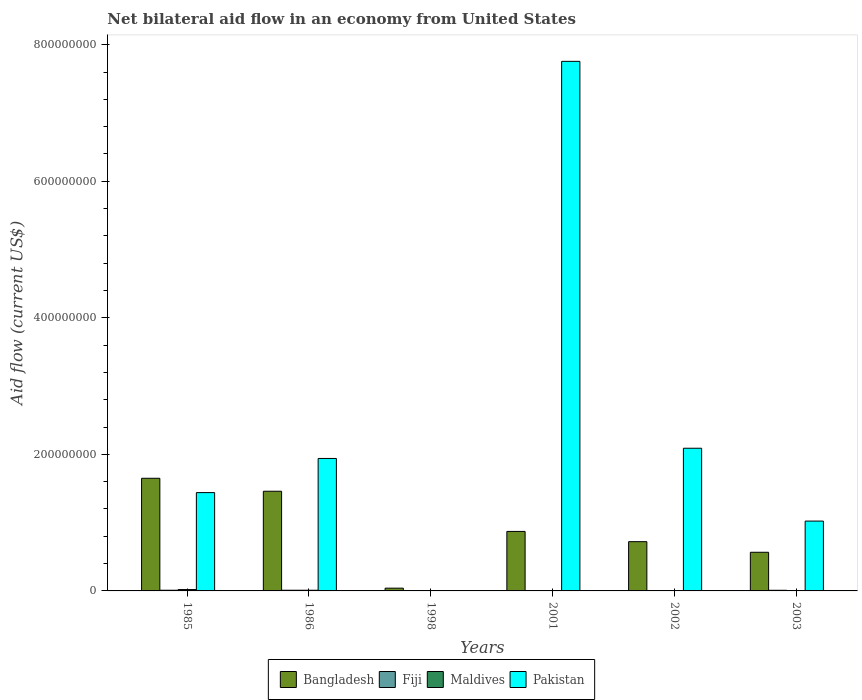Are the number of bars per tick equal to the number of legend labels?
Your answer should be compact. No. How many bars are there on the 5th tick from the right?
Provide a succinct answer. 4. What is the net bilateral aid flow in Bangladesh in 2003?
Ensure brevity in your answer.  5.66e+07. Across all years, what is the maximum net bilateral aid flow in Maldives?
Provide a short and direct response. 2.00e+06. In which year was the net bilateral aid flow in Bangladesh maximum?
Give a very brief answer. 1985. What is the total net bilateral aid flow in Maldives in the graph?
Provide a succinct answer. 3.00e+06. What is the difference between the net bilateral aid flow in Fiji in 1986 and that in 2001?
Offer a very short reply. 9.90e+05. What is the difference between the net bilateral aid flow in Pakistan in 1986 and the net bilateral aid flow in Bangladesh in 2002?
Your response must be concise. 1.22e+08. What is the average net bilateral aid flow in Fiji per year?
Offer a very short reply. 5.42e+05. In the year 2003, what is the difference between the net bilateral aid flow in Fiji and net bilateral aid flow in Pakistan?
Offer a terse response. -1.01e+08. In how many years, is the net bilateral aid flow in Bangladesh greater than 280000000 US$?
Your answer should be very brief. 0. What is the ratio of the net bilateral aid flow in Bangladesh in 1998 to that in 2001?
Your response must be concise. 0.05. What is the difference between the highest and the second highest net bilateral aid flow in Bangladesh?
Provide a succinct answer. 1.90e+07. What is the difference between the highest and the lowest net bilateral aid flow in Bangladesh?
Ensure brevity in your answer.  1.61e+08. In how many years, is the net bilateral aid flow in Bangladesh greater than the average net bilateral aid flow in Bangladesh taken over all years?
Your response must be concise. 2. Is it the case that in every year, the sum of the net bilateral aid flow in Bangladesh and net bilateral aid flow in Fiji is greater than the sum of net bilateral aid flow in Pakistan and net bilateral aid flow in Maldives?
Ensure brevity in your answer.  No. How many bars are there?
Make the answer very short. 19. Are all the bars in the graph horizontal?
Provide a short and direct response. No. Are the values on the major ticks of Y-axis written in scientific E-notation?
Keep it short and to the point. No. Does the graph contain any zero values?
Provide a succinct answer. Yes. Where does the legend appear in the graph?
Ensure brevity in your answer.  Bottom center. What is the title of the graph?
Your answer should be compact. Net bilateral aid flow in an economy from United States. Does "Pakistan" appear as one of the legend labels in the graph?
Your response must be concise. Yes. What is the label or title of the X-axis?
Offer a terse response. Years. What is the label or title of the Y-axis?
Provide a succinct answer. Aid flow (current US$). What is the Aid flow (current US$) in Bangladesh in 1985?
Give a very brief answer. 1.65e+08. What is the Aid flow (current US$) of Pakistan in 1985?
Your answer should be very brief. 1.44e+08. What is the Aid flow (current US$) in Bangladesh in 1986?
Offer a terse response. 1.46e+08. What is the Aid flow (current US$) of Pakistan in 1986?
Your answer should be very brief. 1.94e+08. What is the Aid flow (current US$) of Bangladesh in 1998?
Your response must be concise. 4.04e+06. What is the Aid flow (current US$) of Pakistan in 1998?
Your answer should be very brief. 0. What is the Aid flow (current US$) of Bangladesh in 2001?
Make the answer very short. 8.71e+07. What is the Aid flow (current US$) of Pakistan in 2001?
Your answer should be compact. 7.76e+08. What is the Aid flow (current US$) of Bangladesh in 2002?
Make the answer very short. 7.21e+07. What is the Aid flow (current US$) of Maldives in 2002?
Ensure brevity in your answer.  0. What is the Aid flow (current US$) of Pakistan in 2002?
Make the answer very short. 2.09e+08. What is the Aid flow (current US$) in Bangladesh in 2003?
Offer a terse response. 5.66e+07. What is the Aid flow (current US$) of Fiji in 2003?
Your response must be concise. 9.30e+05. What is the Aid flow (current US$) of Maldives in 2003?
Your answer should be compact. 0. What is the Aid flow (current US$) in Pakistan in 2003?
Your answer should be compact. 1.02e+08. Across all years, what is the maximum Aid flow (current US$) of Bangladesh?
Your answer should be very brief. 1.65e+08. Across all years, what is the maximum Aid flow (current US$) in Fiji?
Keep it short and to the point. 1.00e+06. Across all years, what is the maximum Aid flow (current US$) in Pakistan?
Your answer should be very brief. 7.76e+08. Across all years, what is the minimum Aid flow (current US$) in Bangladesh?
Your answer should be very brief. 4.04e+06. Across all years, what is the minimum Aid flow (current US$) in Fiji?
Give a very brief answer. 10000. Across all years, what is the minimum Aid flow (current US$) in Maldives?
Your answer should be very brief. 0. Across all years, what is the minimum Aid flow (current US$) of Pakistan?
Your answer should be very brief. 0. What is the total Aid flow (current US$) in Bangladesh in the graph?
Your answer should be very brief. 5.31e+08. What is the total Aid flow (current US$) in Fiji in the graph?
Provide a short and direct response. 3.25e+06. What is the total Aid flow (current US$) in Maldives in the graph?
Your answer should be compact. 3.00e+06. What is the total Aid flow (current US$) of Pakistan in the graph?
Keep it short and to the point. 1.42e+09. What is the difference between the Aid flow (current US$) in Bangladesh in 1985 and that in 1986?
Your answer should be compact. 1.90e+07. What is the difference between the Aid flow (current US$) of Fiji in 1985 and that in 1986?
Provide a succinct answer. 0. What is the difference between the Aid flow (current US$) of Maldives in 1985 and that in 1986?
Give a very brief answer. 1.00e+06. What is the difference between the Aid flow (current US$) of Pakistan in 1985 and that in 1986?
Your response must be concise. -5.00e+07. What is the difference between the Aid flow (current US$) in Bangladesh in 1985 and that in 1998?
Your response must be concise. 1.61e+08. What is the difference between the Aid flow (current US$) of Fiji in 1985 and that in 1998?
Offer a very short reply. 7.90e+05. What is the difference between the Aid flow (current US$) of Bangladesh in 1985 and that in 2001?
Make the answer very short. 7.79e+07. What is the difference between the Aid flow (current US$) of Fiji in 1985 and that in 2001?
Your answer should be very brief. 9.90e+05. What is the difference between the Aid flow (current US$) in Pakistan in 1985 and that in 2001?
Provide a short and direct response. -6.32e+08. What is the difference between the Aid flow (current US$) of Bangladesh in 1985 and that in 2002?
Provide a short and direct response. 9.29e+07. What is the difference between the Aid flow (current US$) of Pakistan in 1985 and that in 2002?
Make the answer very short. -6.50e+07. What is the difference between the Aid flow (current US$) in Bangladesh in 1985 and that in 2003?
Make the answer very short. 1.08e+08. What is the difference between the Aid flow (current US$) of Fiji in 1985 and that in 2003?
Give a very brief answer. 7.00e+04. What is the difference between the Aid flow (current US$) of Pakistan in 1985 and that in 2003?
Provide a succinct answer. 4.17e+07. What is the difference between the Aid flow (current US$) in Bangladesh in 1986 and that in 1998?
Keep it short and to the point. 1.42e+08. What is the difference between the Aid flow (current US$) in Fiji in 1986 and that in 1998?
Offer a terse response. 7.90e+05. What is the difference between the Aid flow (current US$) in Bangladesh in 1986 and that in 2001?
Your response must be concise. 5.89e+07. What is the difference between the Aid flow (current US$) of Fiji in 1986 and that in 2001?
Your response must be concise. 9.90e+05. What is the difference between the Aid flow (current US$) in Pakistan in 1986 and that in 2001?
Provide a short and direct response. -5.82e+08. What is the difference between the Aid flow (current US$) in Bangladesh in 1986 and that in 2002?
Offer a terse response. 7.39e+07. What is the difference between the Aid flow (current US$) of Fiji in 1986 and that in 2002?
Your answer should be compact. 9.00e+05. What is the difference between the Aid flow (current US$) of Pakistan in 1986 and that in 2002?
Make the answer very short. -1.50e+07. What is the difference between the Aid flow (current US$) of Bangladesh in 1986 and that in 2003?
Your answer should be compact. 8.94e+07. What is the difference between the Aid flow (current US$) of Fiji in 1986 and that in 2003?
Your answer should be very brief. 7.00e+04. What is the difference between the Aid flow (current US$) of Pakistan in 1986 and that in 2003?
Provide a succinct answer. 9.17e+07. What is the difference between the Aid flow (current US$) of Bangladesh in 1998 and that in 2001?
Offer a terse response. -8.31e+07. What is the difference between the Aid flow (current US$) in Fiji in 1998 and that in 2001?
Offer a very short reply. 2.00e+05. What is the difference between the Aid flow (current US$) of Bangladesh in 1998 and that in 2002?
Ensure brevity in your answer.  -6.81e+07. What is the difference between the Aid flow (current US$) of Bangladesh in 1998 and that in 2003?
Keep it short and to the point. -5.26e+07. What is the difference between the Aid flow (current US$) of Fiji in 1998 and that in 2003?
Your answer should be very brief. -7.20e+05. What is the difference between the Aid flow (current US$) of Bangladesh in 2001 and that in 2002?
Offer a terse response. 1.50e+07. What is the difference between the Aid flow (current US$) in Fiji in 2001 and that in 2002?
Offer a very short reply. -9.00e+04. What is the difference between the Aid flow (current US$) of Pakistan in 2001 and that in 2002?
Provide a short and direct response. 5.67e+08. What is the difference between the Aid flow (current US$) of Bangladesh in 2001 and that in 2003?
Offer a very short reply. 3.05e+07. What is the difference between the Aid flow (current US$) of Fiji in 2001 and that in 2003?
Your response must be concise. -9.20e+05. What is the difference between the Aid flow (current US$) of Pakistan in 2001 and that in 2003?
Make the answer very short. 6.73e+08. What is the difference between the Aid flow (current US$) of Bangladesh in 2002 and that in 2003?
Your answer should be very brief. 1.55e+07. What is the difference between the Aid flow (current US$) of Fiji in 2002 and that in 2003?
Provide a succinct answer. -8.30e+05. What is the difference between the Aid flow (current US$) of Pakistan in 2002 and that in 2003?
Provide a short and direct response. 1.07e+08. What is the difference between the Aid flow (current US$) of Bangladesh in 1985 and the Aid flow (current US$) of Fiji in 1986?
Offer a very short reply. 1.64e+08. What is the difference between the Aid flow (current US$) of Bangladesh in 1985 and the Aid flow (current US$) of Maldives in 1986?
Offer a very short reply. 1.64e+08. What is the difference between the Aid flow (current US$) in Bangladesh in 1985 and the Aid flow (current US$) in Pakistan in 1986?
Keep it short and to the point. -2.90e+07. What is the difference between the Aid flow (current US$) of Fiji in 1985 and the Aid flow (current US$) of Maldives in 1986?
Ensure brevity in your answer.  0. What is the difference between the Aid flow (current US$) of Fiji in 1985 and the Aid flow (current US$) of Pakistan in 1986?
Keep it short and to the point. -1.93e+08. What is the difference between the Aid flow (current US$) of Maldives in 1985 and the Aid flow (current US$) of Pakistan in 1986?
Offer a very short reply. -1.92e+08. What is the difference between the Aid flow (current US$) in Bangladesh in 1985 and the Aid flow (current US$) in Fiji in 1998?
Your answer should be compact. 1.65e+08. What is the difference between the Aid flow (current US$) in Bangladesh in 1985 and the Aid flow (current US$) in Fiji in 2001?
Your answer should be very brief. 1.65e+08. What is the difference between the Aid flow (current US$) of Bangladesh in 1985 and the Aid flow (current US$) of Pakistan in 2001?
Your response must be concise. -6.11e+08. What is the difference between the Aid flow (current US$) in Fiji in 1985 and the Aid flow (current US$) in Pakistan in 2001?
Provide a succinct answer. -7.75e+08. What is the difference between the Aid flow (current US$) in Maldives in 1985 and the Aid flow (current US$) in Pakistan in 2001?
Make the answer very short. -7.74e+08. What is the difference between the Aid flow (current US$) in Bangladesh in 1985 and the Aid flow (current US$) in Fiji in 2002?
Your response must be concise. 1.65e+08. What is the difference between the Aid flow (current US$) in Bangladesh in 1985 and the Aid flow (current US$) in Pakistan in 2002?
Your answer should be compact. -4.40e+07. What is the difference between the Aid flow (current US$) in Fiji in 1985 and the Aid flow (current US$) in Pakistan in 2002?
Your response must be concise. -2.08e+08. What is the difference between the Aid flow (current US$) of Maldives in 1985 and the Aid flow (current US$) of Pakistan in 2002?
Give a very brief answer. -2.07e+08. What is the difference between the Aid flow (current US$) in Bangladesh in 1985 and the Aid flow (current US$) in Fiji in 2003?
Provide a short and direct response. 1.64e+08. What is the difference between the Aid flow (current US$) in Bangladesh in 1985 and the Aid flow (current US$) in Pakistan in 2003?
Make the answer very short. 6.27e+07. What is the difference between the Aid flow (current US$) in Fiji in 1985 and the Aid flow (current US$) in Pakistan in 2003?
Make the answer very short. -1.01e+08. What is the difference between the Aid flow (current US$) in Maldives in 1985 and the Aid flow (current US$) in Pakistan in 2003?
Provide a succinct answer. -1.00e+08. What is the difference between the Aid flow (current US$) of Bangladesh in 1986 and the Aid flow (current US$) of Fiji in 1998?
Your response must be concise. 1.46e+08. What is the difference between the Aid flow (current US$) in Bangladesh in 1986 and the Aid flow (current US$) in Fiji in 2001?
Your answer should be very brief. 1.46e+08. What is the difference between the Aid flow (current US$) of Bangladesh in 1986 and the Aid flow (current US$) of Pakistan in 2001?
Keep it short and to the point. -6.30e+08. What is the difference between the Aid flow (current US$) in Fiji in 1986 and the Aid flow (current US$) in Pakistan in 2001?
Ensure brevity in your answer.  -7.75e+08. What is the difference between the Aid flow (current US$) of Maldives in 1986 and the Aid flow (current US$) of Pakistan in 2001?
Give a very brief answer. -7.75e+08. What is the difference between the Aid flow (current US$) in Bangladesh in 1986 and the Aid flow (current US$) in Fiji in 2002?
Provide a succinct answer. 1.46e+08. What is the difference between the Aid flow (current US$) of Bangladesh in 1986 and the Aid flow (current US$) of Pakistan in 2002?
Your answer should be very brief. -6.30e+07. What is the difference between the Aid flow (current US$) in Fiji in 1986 and the Aid flow (current US$) in Pakistan in 2002?
Provide a succinct answer. -2.08e+08. What is the difference between the Aid flow (current US$) in Maldives in 1986 and the Aid flow (current US$) in Pakistan in 2002?
Your answer should be very brief. -2.08e+08. What is the difference between the Aid flow (current US$) of Bangladesh in 1986 and the Aid flow (current US$) of Fiji in 2003?
Ensure brevity in your answer.  1.45e+08. What is the difference between the Aid flow (current US$) in Bangladesh in 1986 and the Aid flow (current US$) in Pakistan in 2003?
Keep it short and to the point. 4.37e+07. What is the difference between the Aid flow (current US$) in Fiji in 1986 and the Aid flow (current US$) in Pakistan in 2003?
Your answer should be very brief. -1.01e+08. What is the difference between the Aid flow (current US$) in Maldives in 1986 and the Aid flow (current US$) in Pakistan in 2003?
Provide a short and direct response. -1.01e+08. What is the difference between the Aid flow (current US$) in Bangladesh in 1998 and the Aid flow (current US$) in Fiji in 2001?
Keep it short and to the point. 4.03e+06. What is the difference between the Aid flow (current US$) of Bangladesh in 1998 and the Aid flow (current US$) of Pakistan in 2001?
Give a very brief answer. -7.72e+08. What is the difference between the Aid flow (current US$) of Fiji in 1998 and the Aid flow (current US$) of Pakistan in 2001?
Give a very brief answer. -7.75e+08. What is the difference between the Aid flow (current US$) of Bangladesh in 1998 and the Aid flow (current US$) of Fiji in 2002?
Your answer should be compact. 3.94e+06. What is the difference between the Aid flow (current US$) in Bangladesh in 1998 and the Aid flow (current US$) in Pakistan in 2002?
Offer a very short reply. -2.05e+08. What is the difference between the Aid flow (current US$) of Fiji in 1998 and the Aid flow (current US$) of Pakistan in 2002?
Ensure brevity in your answer.  -2.09e+08. What is the difference between the Aid flow (current US$) of Bangladesh in 1998 and the Aid flow (current US$) of Fiji in 2003?
Provide a succinct answer. 3.11e+06. What is the difference between the Aid flow (current US$) of Bangladesh in 1998 and the Aid flow (current US$) of Pakistan in 2003?
Offer a terse response. -9.82e+07. What is the difference between the Aid flow (current US$) of Fiji in 1998 and the Aid flow (current US$) of Pakistan in 2003?
Provide a succinct answer. -1.02e+08. What is the difference between the Aid flow (current US$) in Bangladesh in 2001 and the Aid flow (current US$) in Fiji in 2002?
Give a very brief answer. 8.70e+07. What is the difference between the Aid flow (current US$) in Bangladesh in 2001 and the Aid flow (current US$) in Pakistan in 2002?
Your response must be concise. -1.22e+08. What is the difference between the Aid flow (current US$) of Fiji in 2001 and the Aid flow (current US$) of Pakistan in 2002?
Give a very brief answer. -2.09e+08. What is the difference between the Aid flow (current US$) of Bangladesh in 2001 and the Aid flow (current US$) of Fiji in 2003?
Keep it short and to the point. 8.62e+07. What is the difference between the Aid flow (current US$) in Bangladesh in 2001 and the Aid flow (current US$) in Pakistan in 2003?
Ensure brevity in your answer.  -1.52e+07. What is the difference between the Aid flow (current US$) in Fiji in 2001 and the Aid flow (current US$) in Pakistan in 2003?
Offer a terse response. -1.02e+08. What is the difference between the Aid flow (current US$) of Bangladesh in 2002 and the Aid flow (current US$) of Fiji in 2003?
Your answer should be compact. 7.12e+07. What is the difference between the Aid flow (current US$) in Bangladesh in 2002 and the Aid flow (current US$) in Pakistan in 2003?
Keep it short and to the point. -3.01e+07. What is the difference between the Aid flow (current US$) of Fiji in 2002 and the Aid flow (current US$) of Pakistan in 2003?
Your response must be concise. -1.02e+08. What is the average Aid flow (current US$) of Bangladesh per year?
Make the answer very short. 8.85e+07. What is the average Aid flow (current US$) in Fiji per year?
Offer a terse response. 5.42e+05. What is the average Aid flow (current US$) of Maldives per year?
Offer a terse response. 5.00e+05. What is the average Aid flow (current US$) of Pakistan per year?
Your response must be concise. 2.37e+08. In the year 1985, what is the difference between the Aid flow (current US$) of Bangladesh and Aid flow (current US$) of Fiji?
Your answer should be compact. 1.64e+08. In the year 1985, what is the difference between the Aid flow (current US$) of Bangladesh and Aid flow (current US$) of Maldives?
Keep it short and to the point. 1.63e+08. In the year 1985, what is the difference between the Aid flow (current US$) of Bangladesh and Aid flow (current US$) of Pakistan?
Your answer should be very brief. 2.10e+07. In the year 1985, what is the difference between the Aid flow (current US$) of Fiji and Aid flow (current US$) of Pakistan?
Keep it short and to the point. -1.43e+08. In the year 1985, what is the difference between the Aid flow (current US$) of Maldives and Aid flow (current US$) of Pakistan?
Make the answer very short. -1.42e+08. In the year 1986, what is the difference between the Aid flow (current US$) in Bangladesh and Aid flow (current US$) in Fiji?
Ensure brevity in your answer.  1.45e+08. In the year 1986, what is the difference between the Aid flow (current US$) in Bangladesh and Aid flow (current US$) in Maldives?
Your answer should be very brief. 1.45e+08. In the year 1986, what is the difference between the Aid flow (current US$) in Bangladesh and Aid flow (current US$) in Pakistan?
Make the answer very short. -4.80e+07. In the year 1986, what is the difference between the Aid flow (current US$) of Fiji and Aid flow (current US$) of Maldives?
Provide a succinct answer. 0. In the year 1986, what is the difference between the Aid flow (current US$) of Fiji and Aid flow (current US$) of Pakistan?
Offer a very short reply. -1.93e+08. In the year 1986, what is the difference between the Aid flow (current US$) in Maldives and Aid flow (current US$) in Pakistan?
Your answer should be very brief. -1.93e+08. In the year 1998, what is the difference between the Aid flow (current US$) of Bangladesh and Aid flow (current US$) of Fiji?
Make the answer very short. 3.83e+06. In the year 2001, what is the difference between the Aid flow (current US$) in Bangladesh and Aid flow (current US$) in Fiji?
Provide a short and direct response. 8.71e+07. In the year 2001, what is the difference between the Aid flow (current US$) of Bangladesh and Aid flow (current US$) of Pakistan?
Keep it short and to the point. -6.89e+08. In the year 2001, what is the difference between the Aid flow (current US$) of Fiji and Aid flow (current US$) of Pakistan?
Offer a very short reply. -7.76e+08. In the year 2002, what is the difference between the Aid flow (current US$) of Bangladesh and Aid flow (current US$) of Fiji?
Make the answer very short. 7.20e+07. In the year 2002, what is the difference between the Aid flow (current US$) in Bangladesh and Aid flow (current US$) in Pakistan?
Your response must be concise. -1.37e+08. In the year 2002, what is the difference between the Aid flow (current US$) of Fiji and Aid flow (current US$) of Pakistan?
Provide a succinct answer. -2.09e+08. In the year 2003, what is the difference between the Aid flow (current US$) in Bangladesh and Aid flow (current US$) in Fiji?
Offer a very short reply. 5.57e+07. In the year 2003, what is the difference between the Aid flow (current US$) in Bangladesh and Aid flow (current US$) in Pakistan?
Offer a terse response. -4.57e+07. In the year 2003, what is the difference between the Aid flow (current US$) of Fiji and Aid flow (current US$) of Pakistan?
Your answer should be very brief. -1.01e+08. What is the ratio of the Aid flow (current US$) in Bangladesh in 1985 to that in 1986?
Provide a short and direct response. 1.13. What is the ratio of the Aid flow (current US$) in Fiji in 1985 to that in 1986?
Provide a succinct answer. 1. What is the ratio of the Aid flow (current US$) of Pakistan in 1985 to that in 1986?
Keep it short and to the point. 0.74. What is the ratio of the Aid flow (current US$) in Bangladesh in 1985 to that in 1998?
Provide a succinct answer. 40.84. What is the ratio of the Aid flow (current US$) in Fiji in 1985 to that in 1998?
Your answer should be very brief. 4.76. What is the ratio of the Aid flow (current US$) in Bangladesh in 1985 to that in 2001?
Give a very brief answer. 1.89. What is the ratio of the Aid flow (current US$) in Pakistan in 1985 to that in 2001?
Provide a succinct answer. 0.19. What is the ratio of the Aid flow (current US$) in Bangladesh in 1985 to that in 2002?
Your answer should be compact. 2.29. What is the ratio of the Aid flow (current US$) of Pakistan in 1985 to that in 2002?
Ensure brevity in your answer.  0.69. What is the ratio of the Aid flow (current US$) of Bangladesh in 1985 to that in 2003?
Ensure brevity in your answer.  2.91. What is the ratio of the Aid flow (current US$) in Fiji in 1985 to that in 2003?
Your answer should be very brief. 1.08. What is the ratio of the Aid flow (current US$) of Pakistan in 1985 to that in 2003?
Give a very brief answer. 1.41. What is the ratio of the Aid flow (current US$) of Bangladesh in 1986 to that in 1998?
Ensure brevity in your answer.  36.14. What is the ratio of the Aid flow (current US$) of Fiji in 1986 to that in 1998?
Ensure brevity in your answer.  4.76. What is the ratio of the Aid flow (current US$) of Bangladesh in 1986 to that in 2001?
Your answer should be very brief. 1.68. What is the ratio of the Aid flow (current US$) in Fiji in 1986 to that in 2001?
Offer a very short reply. 100. What is the ratio of the Aid flow (current US$) of Pakistan in 1986 to that in 2001?
Provide a succinct answer. 0.25. What is the ratio of the Aid flow (current US$) of Bangladesh in 1986 to that in 2002?
Your answer should be very brief. 2.02. What is the ratio of the Aid flow (current US$) in Pakistan in 1986 to that in 2002?
Offer a very short reply. 0.93. What is the ratio of the Aid flow (current US$) in Bangladesh in 1986 to that in 2003?
Keep it short and to the point. 2.58. What is the ratio of the Aid flow (current US$) in Fiji in 1986 to that in 2003?
Give a very brief answer. 1.08. What is the ratio of the Aid flow (current US$) in Pakistan in 1986 to that in 2003?
Offer a terse response. 1.9. What is the ratio of the Aid flow (current US$) of Bangladesh in 1998 to that in 2001?
Your answer should be very brief. 0.05. What is the ratio of the Aid flow (current US$) in Fiji in 1998 to that in 2001?
Give a very brief answer. 21. What is the ratio of the Aid flow (current US$) of Bangladesh in 1998 to that in 2002?
Your response must be concise. 0.06. What is the ratio of the Aid flow (current US$) of Fiji in 1998 to that in 2002?
Provide a succinct answer. 2.1. What is the ratio of the Aid flow (current US$) in Bangladesh in 1998 to that in 2003?
Give a very brief answer. 0.07. What is the ratio of the Aid flow (current US$) in Fiji in 1998 to that in 2003?
Provide a short and direct response. 0.23. What is the ratio of the Aid flow (current US$) of Bangladesh in 2001 to that in 2002?
Provide a succinct answer. 1.21. What is the ratio of the Aid flow (current US$) of Fiji in 2001 to that in 2002?
Keep it short and to the point. 0.1. What is the ratio of the Aid flow (current US$) of Pakistan in 2001 to that in 2002?
Offer a terse response. 3.71. What is the ratio of the Aid flow (current US$) in Bangladesh in 2001 to that in 2003?
Your response must be concise. 1.54. What is the ratio of the Aid flow (current US$) in Fiji in 2001 to that in 2003?
Ensure brevity in your answer.  0.01. What is the ratio of the Aid flow (current US$) of Pakistan in 2001 to that in 2003?
Provide a succinct answer. 7.58. What is the ratio of the Aid flow (current US$) of Bangladesh in 2002 to that in 2003?
Your answer should be very brief. 1.27. What is the ratio of the Aid flow (current US$) of Fiji in 2002 to that in 2003?
Your response must be concise. 0.11. What is the ratio of the Aid flow (current US$) in Pakistan in 2002 to that in 2003?
Make the answer very short. 2.04. What is the difference between the highest and the second highest Aid flow (current US$) in Bangladesh?
Your answer should be very brief. 1.90e+07. What is the difference between the highest and the second highest Aid flow (current US$) of Fiji?
Provide a short and direct response. 0. What is the difference between the highest and the second highest Aid flow (current US$) in Pakistan?
Give a very brief answer. 5.67e+08. What is the difference between the highest and the lowest Aid flow (current US$) in Bangladesh?
Keep it short and to the point. 1.61e+08. What is the difference between the highest and the lowest Aid flow (current US$) in Fiji?
Offer a very short reply. 9.90e+05. What is the difference between the highest and the lowest Aid flow (current US$) in Pakistan?
Provide a succinct answer. 7.76e+08. 